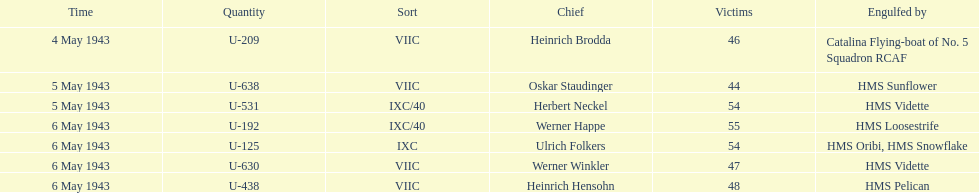How many more casualties occurred on may 6 compared to may 4? 158. 